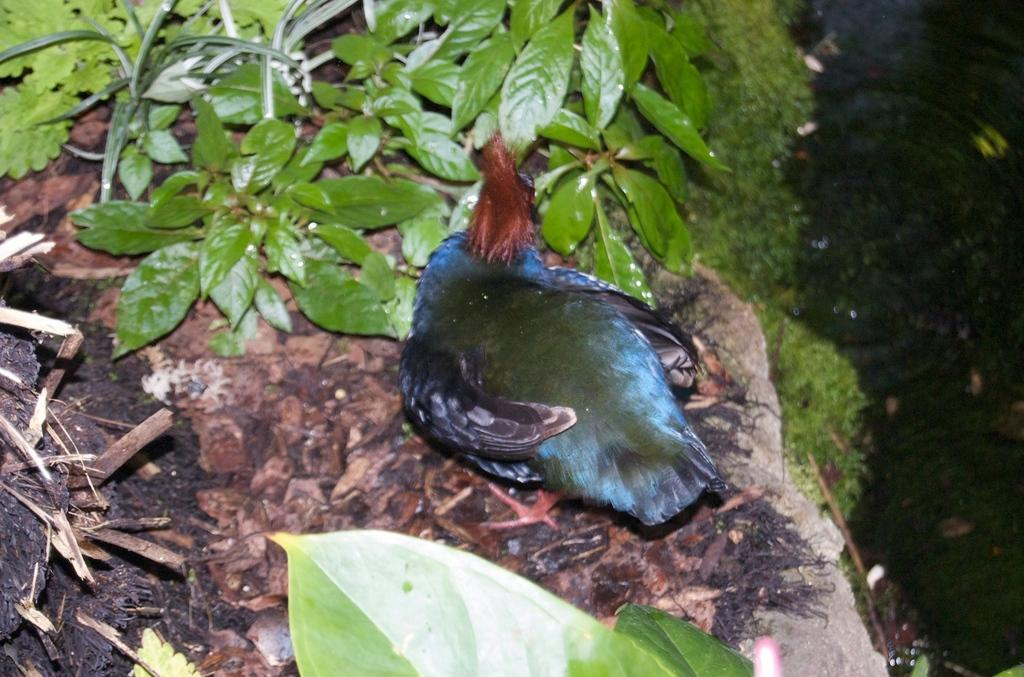What type of animal can be seen in the image? There is a bird in the image. What can be seen at the top of the image? Plants and grass are visible at the top of the image. What is visible on the right side of the image? Water is visible on the right side of the image. What is visible at the bottom of the image? Leaves are visible at the bottom of the image. What type of muscle is being exercised by the bird in the image? There is no indication in the image that the bird is exercising any muscles, and therefore no such activity can be observed. 